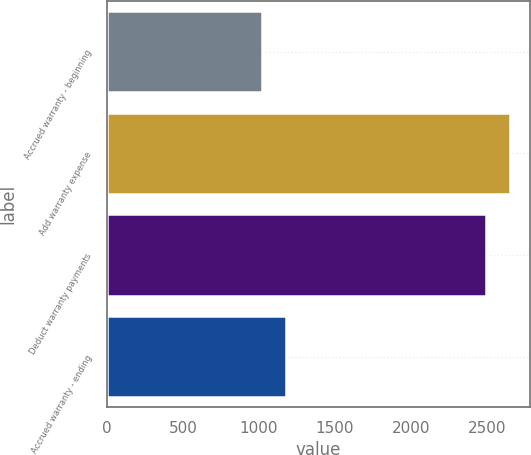<chart> <loc_0><loc_0><loc_500><loc_500><bar_chart><fcel>Accrued warranty - beginning<fcel>Add warranty expense<fcel>Deduct warranty payments<fcel>Accrued warranty - ending<nl><fcel>1021<fcel>2649.3<fcel>2495<fcel>1175.3<nl></chart> 